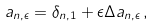<formula> <loc_0><loc_0><loc_500><loc_500>a _ { n , \epsilon } = \delta _ { n , 1 } + \epsilon \Delta a _ { n , \epsilon } \, ,</formula> 